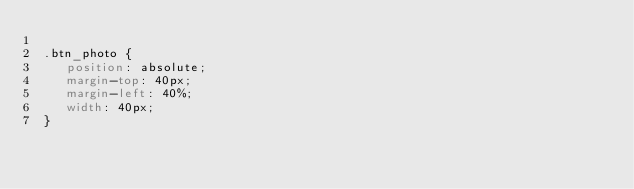Convert code to text. <code><loc_0><loc_0><loc_500><loc_500><_CSS_> 
 .btn_photo {
 	position: absolute;
 	margin-top: 40px;
 	margin-left: 40%;
 	width: 40px;
 }
 </code> 